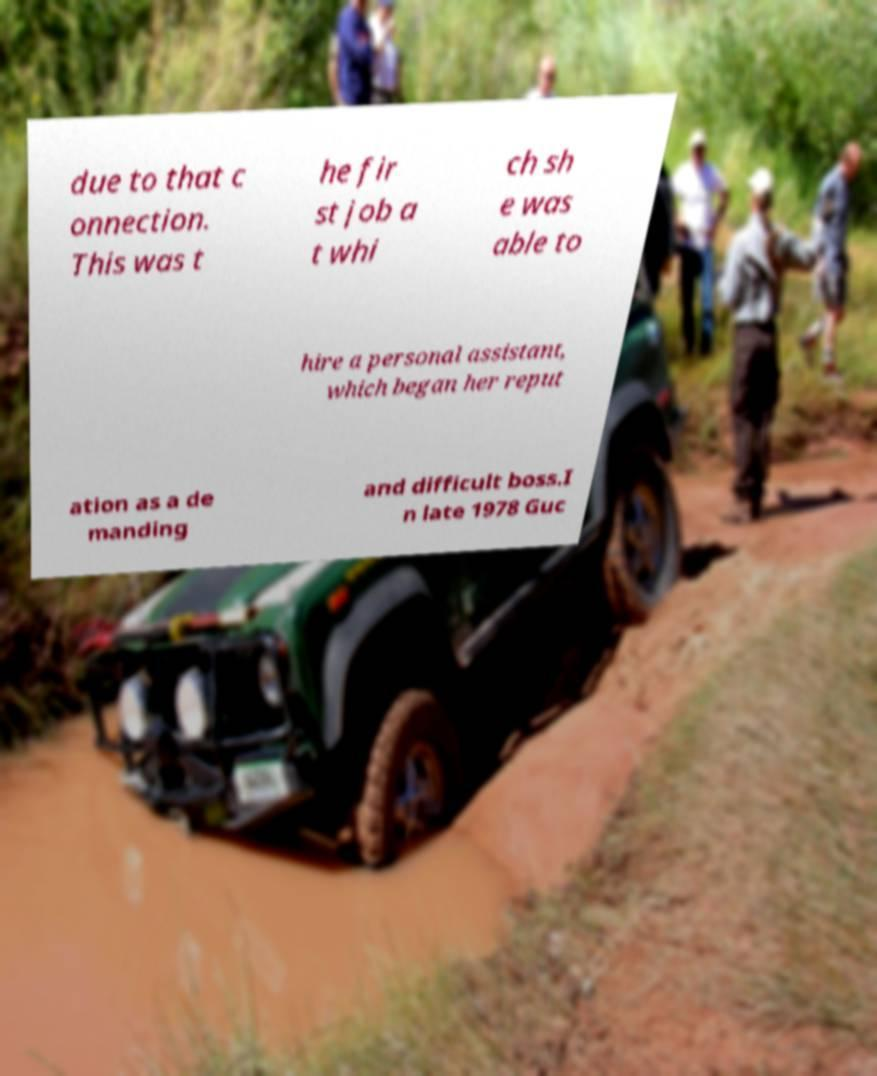Please read and relay the text visible in this image. What does it say? due to that c onnection. This was t he fir st job a t whi ch sh e was able to hire a personal assistant, which began her reput ation as a de manding and difficult boss.I n late 1978 Guc 